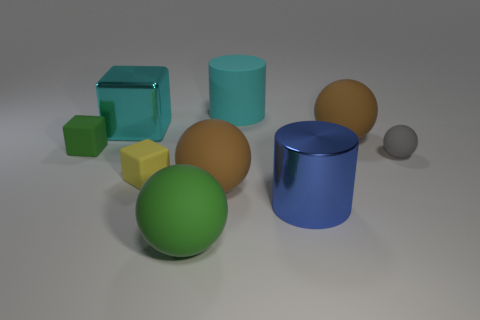What is the size of the green object that is the same shape as the small gray matte thing?
Give a very brief answer. Large. What number of small objects are either yellow objects or brown matte cylinders?
Give a very brief answer. 1. Is there anything else that is the same color as the metal cylinder?
Offer a very short reply. No. What is the material of the cylinder in front of the sphere that is to the right of the brown object on the right side of the big cyan cylinder?
Provide a short and direct response. Metal. What number of metal things are either yellow cubes or tiny purple balls?
Your response must be concise. 0. What number of cyan objects are either small rubber blocks or matte objects?
Your response must be concise. 1. Do the metallic object that is on the left side of the big cyan cylinder and the large matte cylinder have the same color?
Provide a short and direct response. Yes. Does the large blue cylinder have the same material as the large block?
Your answer should be very brief. Yes. Are there an equal number of large metallic things that are on the right side of the green matte block and big metallic things in front of the yellow matte thing?
Give a very brief answer. No. What material is the other tiny thing that is the same shape as the yellow object?
Give a very brief answer. Rubber. 